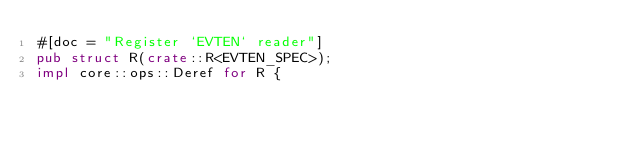Convert code to text. <code><loc_0><loc_0><loc_500><loc_500><_Rust_>#[doc = "Register `EVTEN` reader"]
pub struct R(crate::R<EVTEN_SPEC>);
impl core::ops::Deref for R {</code> 